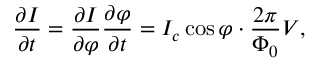<formula> <loc_0><loc_0><loc_500><loc_500>{ \frac { \partial I } { \partial t } } = { \frac { \partial I } { \partial \varphi } } { \frac { \partial \varphi } { \partial t } } = I _ { c } \cos \varphi \cdot { \frac { 2 \pi } { \Phi _ { 0 } } } V ,</formula> 